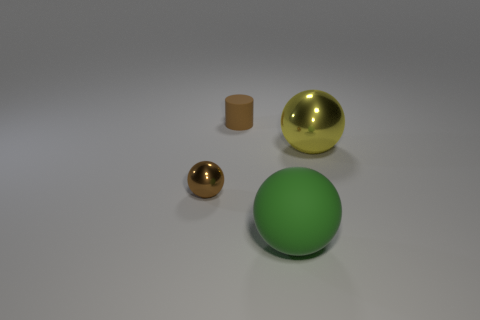Subtract all gray spheres. Subtract all purple cylinders. How many spheres are left? 3 Add 4 big green things. How many objects exist? 8 Subtract all cylinders. How many objects are left? 3 Add 4 brown cylinders. How many brown cylinders exist? 5 Subtract 0 yellow cylinders. How many objects are left? 4 Subtract all blue shiny balls. Subtract all tiny brown matte cylinders. How many objects are left? 3 Add 3 small rubber objects. How many small rubber objects are left? 4 